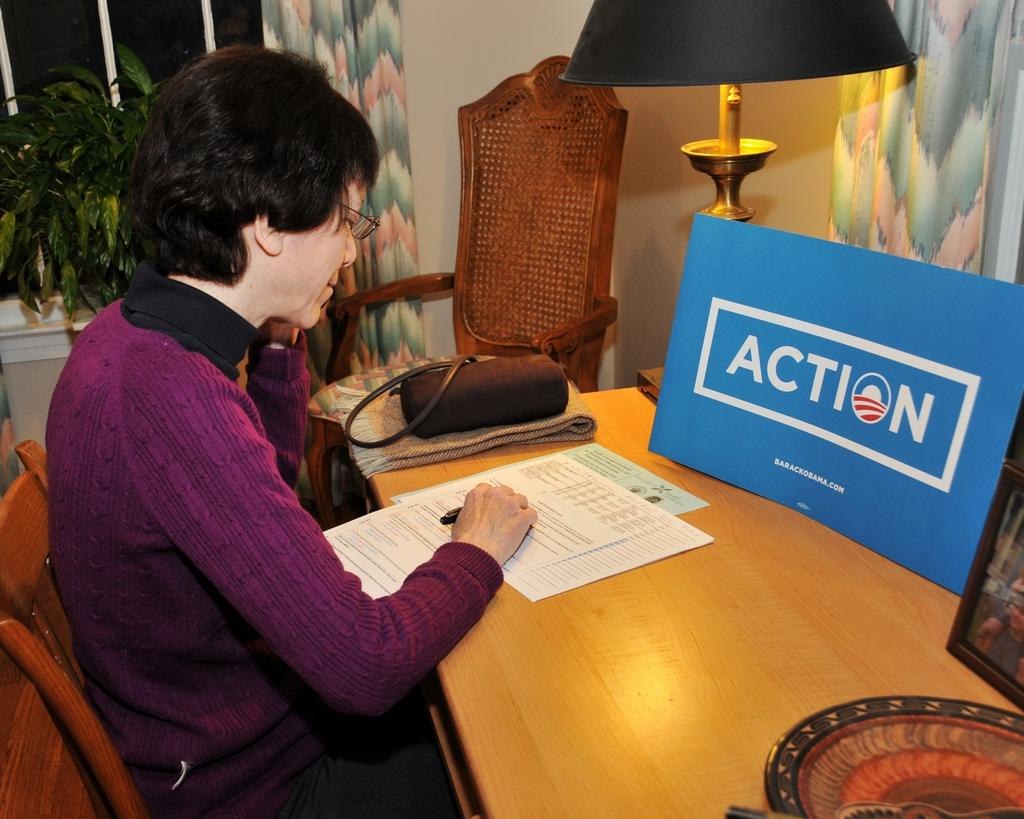<image>
Share a concise interpretation of the image provided. A woman with a blue sign in front of her with the word action written on it. 